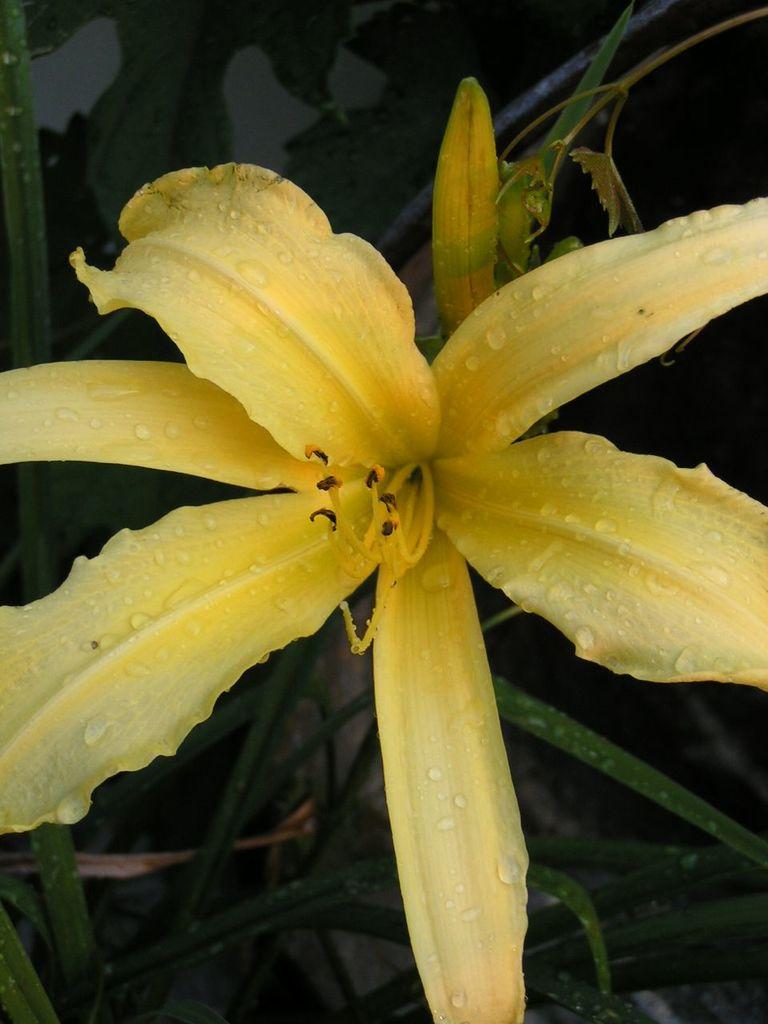What type of living organism can be seen in the image? There is a flower in the image. Are there any other plants visible in the image? Yes, there are plants in the image. What type of screw can be seen holding the sweater in the image? There is no screw or sweater present in the image; it only features a flower and other plants. 